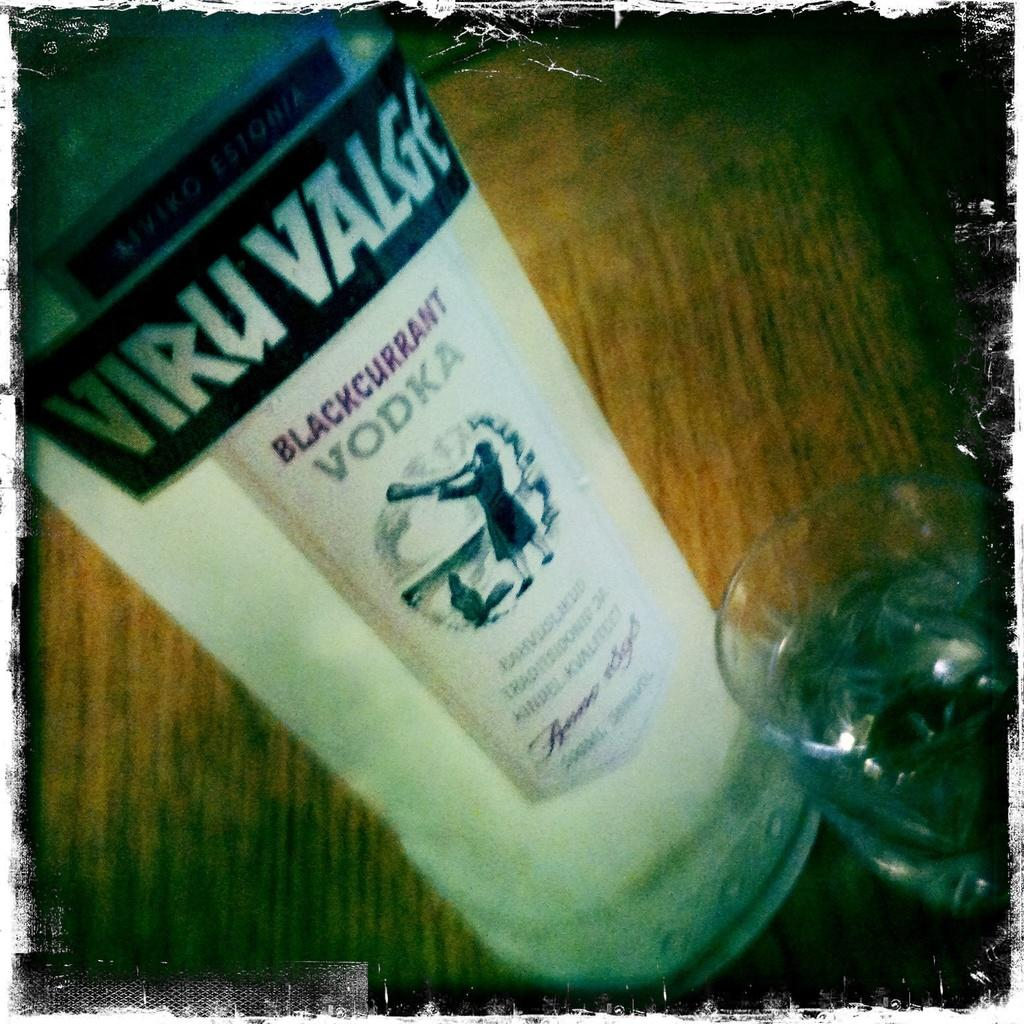<image>
Write a terse but informative summary of the picture. A white bottle of Blackcurrent vodka branded Viru Valge. 